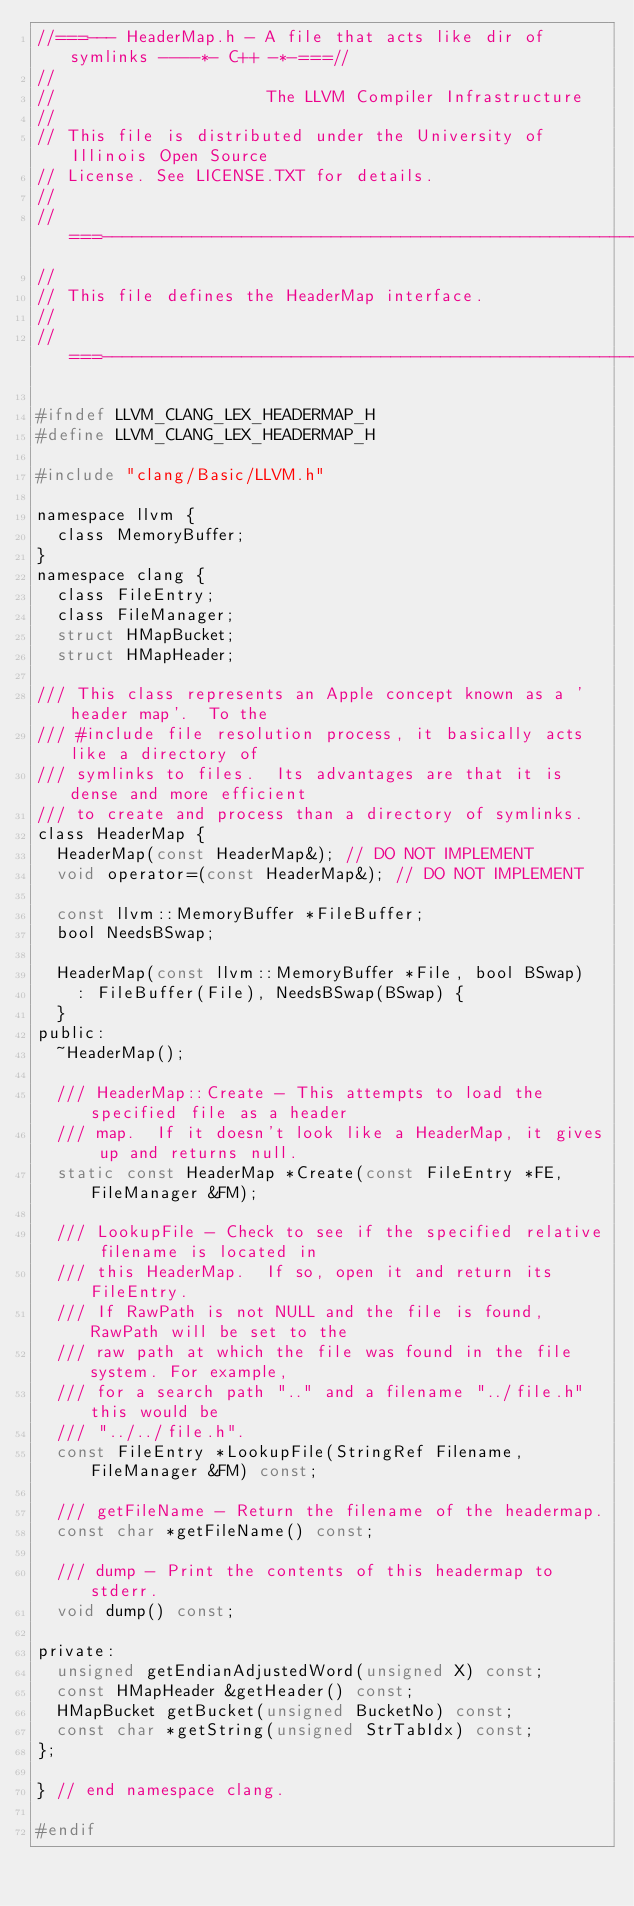<code> <loc_0><loc_0><loc_500><loc_500><_C_>//===--- HeaderMap.h - A file that acts like dir of symlinks ----*- C++ -*-===//
//
//                     The LLVM Compiler Infrastructure
//
// This file is distributed under the University of Illinois Open Source
// License. See LICENSE.TXT for details.
//
//===----------------------------------------------------------------------===//
//
// This file defines the HeaderMap interface.
//
//===----------------------------------------------------------------------===//

#ifndef LLVM_CLANG_LEX_HEADERMAP_H
#define LLVM_CLANG_LEX_HEADERMAP_H

#include "clang/Basic/LLVM.h"

namespace llvm {
  class MemoryBuffer;
}
namespace clang {
  class FileEntry;
  class FileManager;
  struct HMapBucket;
  struct HMapHeader;

/// This class represents an Apple concept known as a 'header map'.  To the
/// #include file resolution process, it basically acts like a directory of
/// symlinks to files.  Its advantages are that it is dense and more efficient
/// to create and process than a directory of symlinks.
class HeaderMap {
  HeaderMap(const HeaderMap&); // DO NOT IMPLEMENT
  void operator=(const HeaderMap&); // DO NOT IMPLEMENT

  const llvm::MemoryBuffer *FileBuffer;
  bool NeedsBSwap;

  HeaderMap(const llvm::MemoryBuffer *File, bool BSwap)
    : FileBuffer(File), NeedsBSwap(BSwap) {
  }
public:
  ~HeaderMap();

  /// HeaderMap::Create - This attempts to load the specified file as a header
  /// map.  If it doesn't look like a HeaderMap, it gives up and returns null.
  static const HeaderMap *Create(const FileEntry *FE, FileManager &FM);

  /// LookupFile - Check to see if the specified relative filename is located in
  /// this HeaderMap.  If so, open it and return its FileEntry.
  /// If RawPath is not NULL and the file is found, RawPath will be set to the
  /// raw path at which the file was found in the file system. For example,
  /// for a search path ".." and a filename "../file.h" this would be
  /// "../../file.h".
  const FileEntry *LookupFile(StringRef Filename, FileManager &FM) const;

  /// getFileName - Return the filename of the headermap.
  const char *getFileName() const;

  /// dump - Print the contents of this headermap to stderr.
  void dump() const;

private:
  unsigned getEndianAdjustedWord(unsigned X) const;
  const HMapHeader &getHeader() const;
  HMapBucket getBucket(unsigned BucketNo) const;
  const char *getString(unsigned StrTabIdx) const;
};

} // end namespace clang.

#endif
</code> 